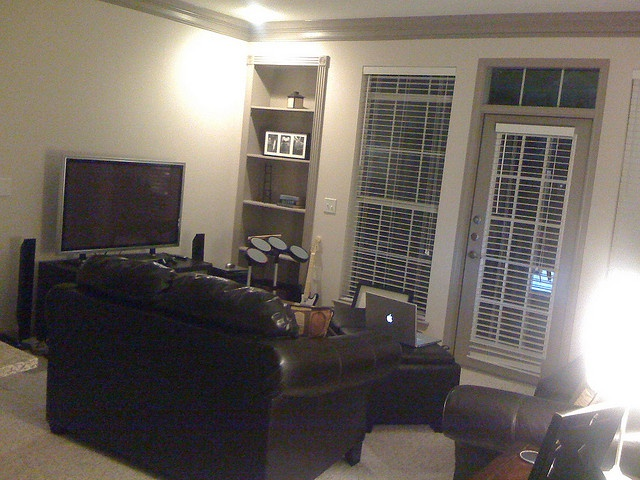Describe the objects in this image and their specific colors. I can see couch in olive, black, navy, and gray tones, tv in olive, black, gray, and navy tones, chair in olive, gray, black, and purple tones, couch in olive, black, gray, and purple tones, and chair in olive, gray, darkgray, white, and black tones in this image. 